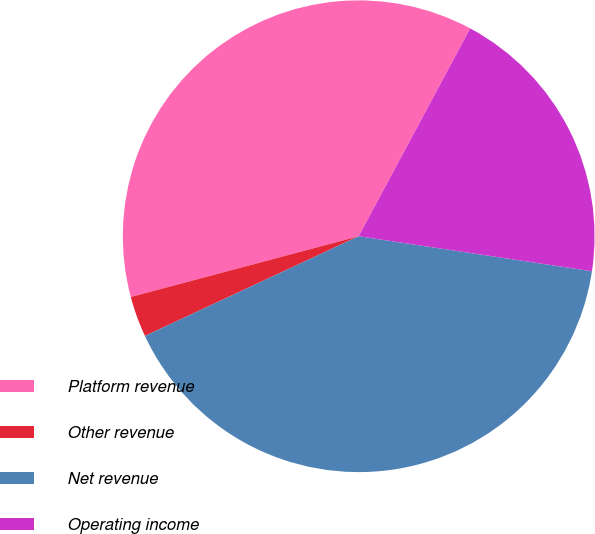Convert chart to OTSL. <chart><loc_0><loc_0><loc_500><loc_500><pie_chart><fcel>Platform revenue<fcel>Other revenue<fcel>Net revenue<fcel>Operating income<nl><fcel>36.98%<fcel>2.8%<fcel>40.68%<fcel>19.53%<nl></chart> 